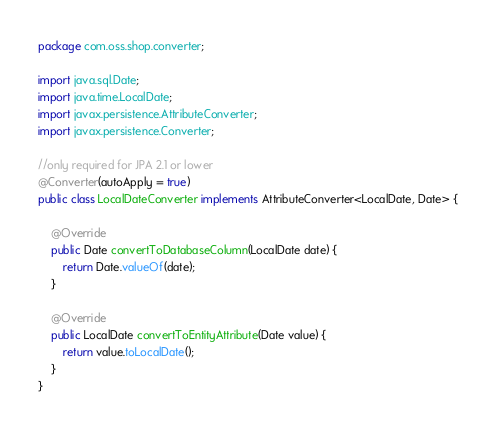<code> <loc_0><loc_0><loc_500><loc_500><_Java_>package com.oss.shop.converter;

import java.sql.Date;
import java.time.LocalDate;
import javax.persistence.AttributeConverter;
import javax.persistence.Converter;

//only required for JPA 2.1 or lower
@Converter(autoApply = true)
public class LocalDateConverter implements AttributeConverter<LocalDate, Date> {

    @Override
    public Date convertToDatabaseColumn(LocalDate date) {        
        return Date.valueOf(date);
    }

    @Override
    public LocalDate convertToEntityAttribute(Date value) {
        return value.toLocalDate();
    }
}
</code> 